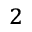Convert formula to latex. <formula><loc_0><loc_0><loc_500><loc_500>^ { 2 }</formula> 